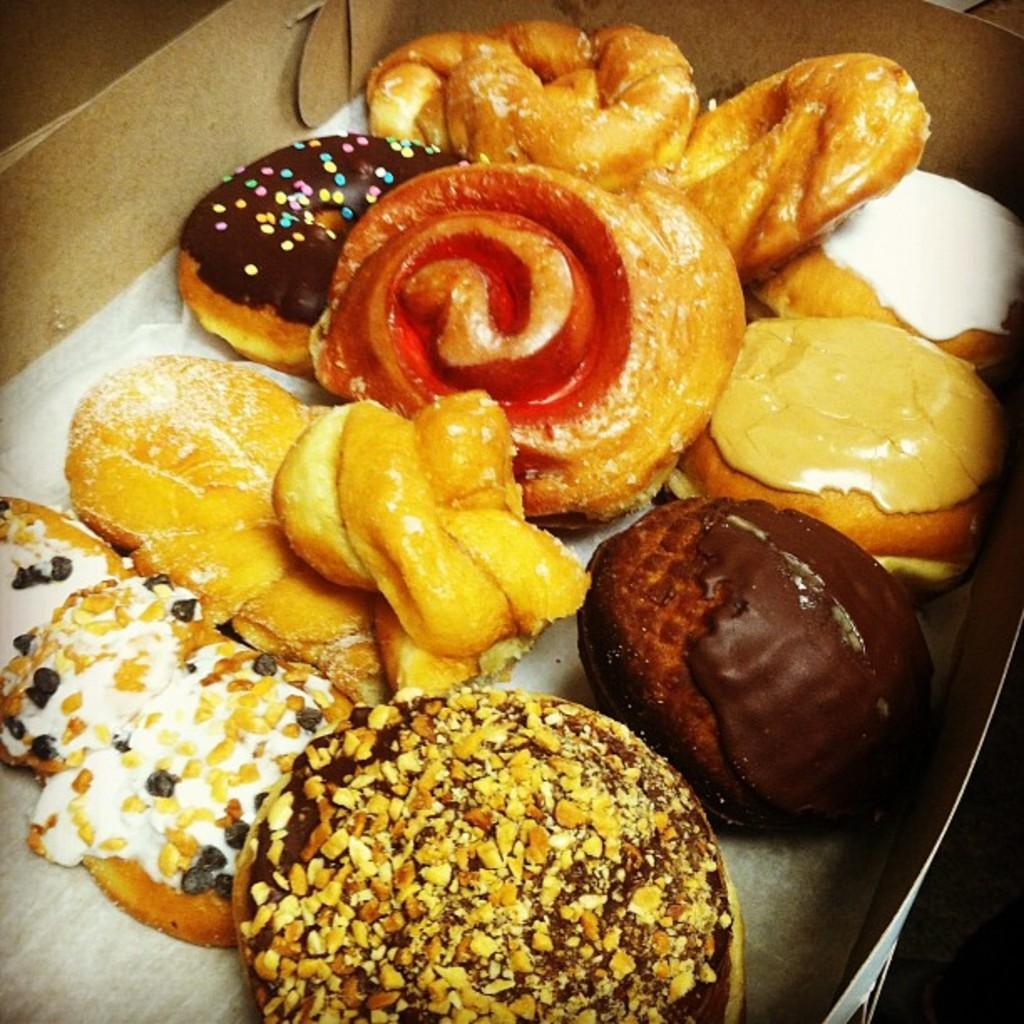What is present in the image? There are food items in the image. How are the food items arranged or contained? The food items are placed in a box. What type of star can be seen in the bedroom in the image? There is no bedroom or star present in the image; it only contains food items placed in a box. 